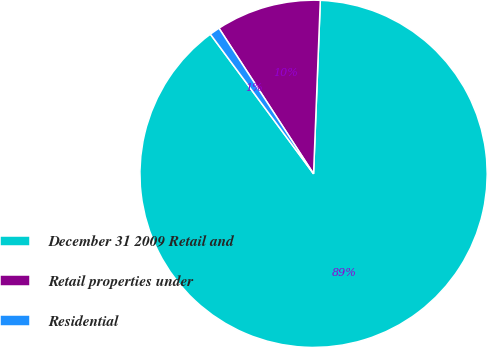Convert chart. <chart><loc_0><loc_0><loc_500><loc_500><pie_chart><fcel>December 31 2009 Retail and<fcel>Retail properties under<fcel>Residential<nl><fcel>89.25%<fcel>9.79%<fcel>0.96%<nl></chart> 